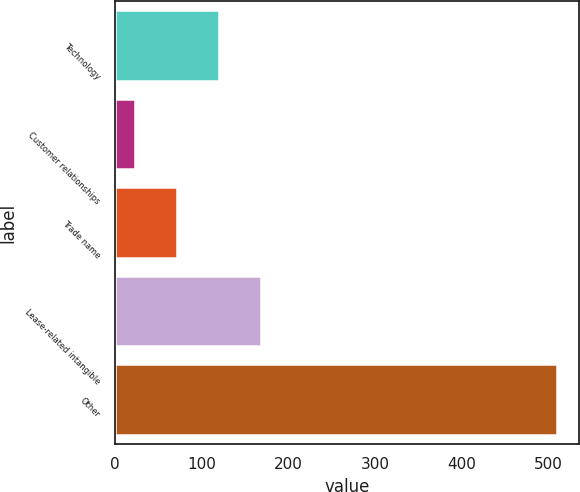Convert chart. <chart><loc_0><loc_0><loc_500><loc_500><bar_chart><fcel>Technology<fcel>Customer relationships<fcel>Trade name<fcel>Lease-related intangible<fcel>Other<nl><fcel>120.4<fcel>23<fcel>71.7<fcel>169.1<fcel>510<nl></chart> 